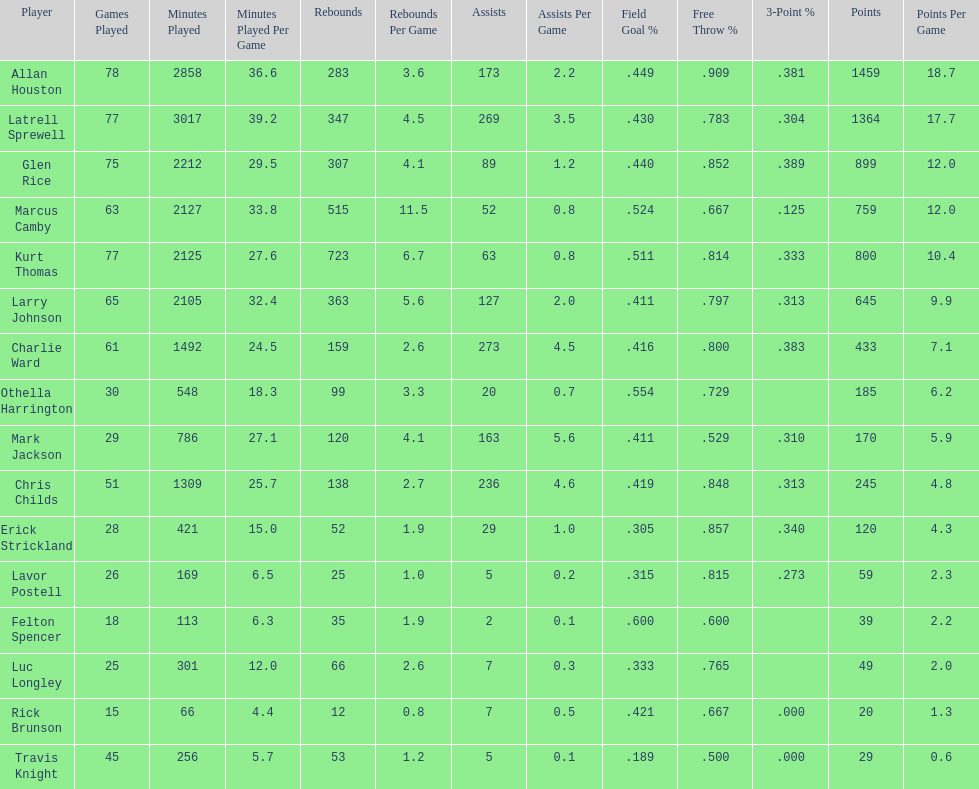Number of players on the team. 16. 